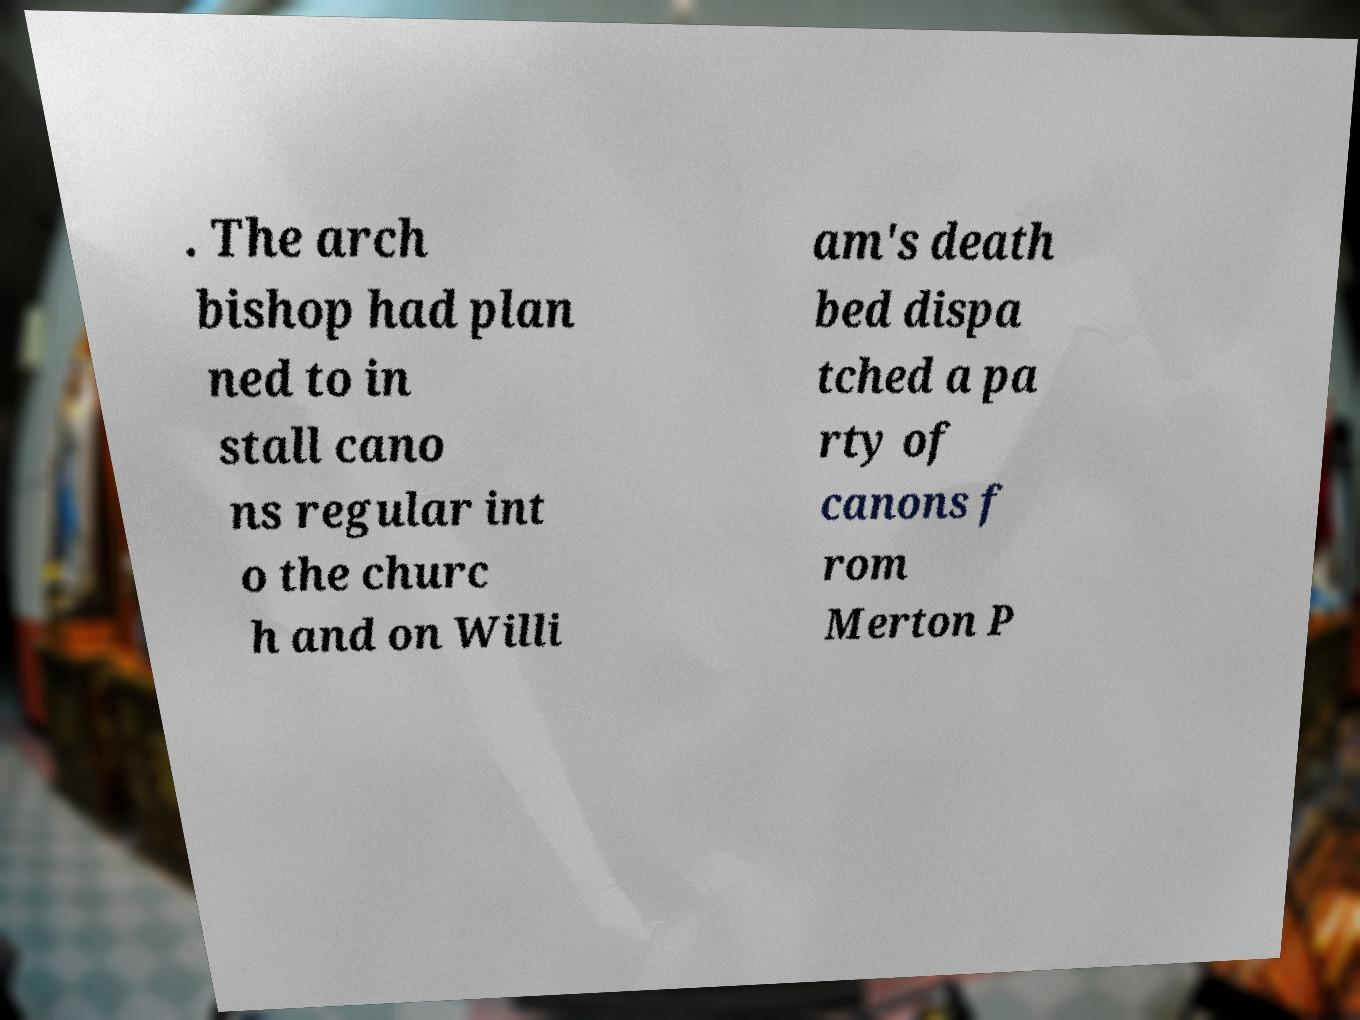Can you accurately transcribe the text from the provided image for me? . The arch bishop had plan ned to in stall cano ns regular int o the churc h and on Willi am's death bed dispa tched a pa rty of canons f rom Merton P 